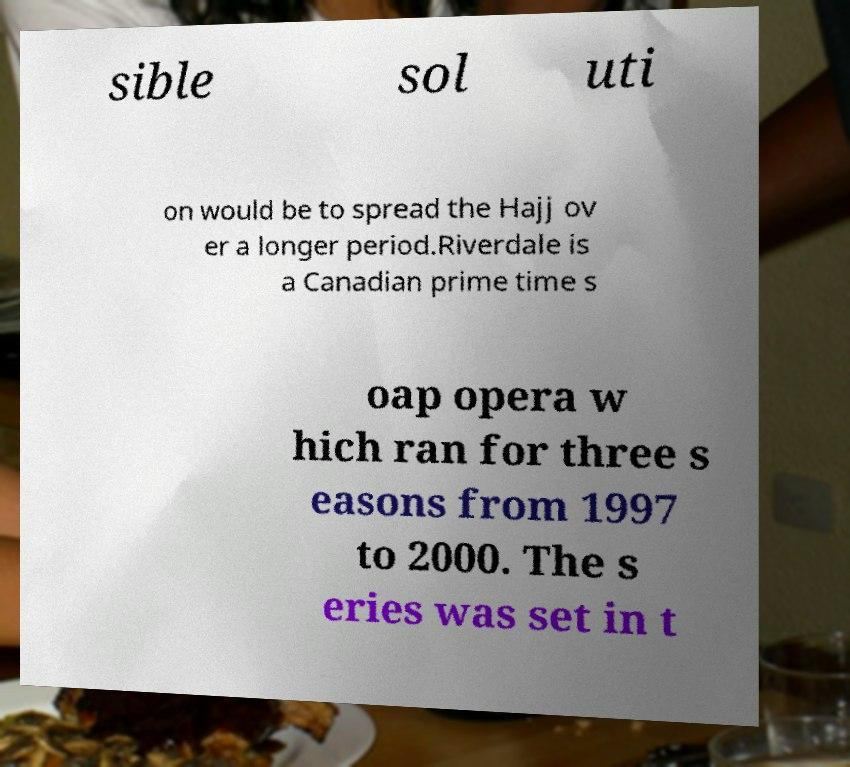Please identify and transcribe the text found in this image. sible sol uti on would be to spread the Hajj ov er a longer period.Riverdale is a Canadian prime time s oap opera w hich ran for three s easons from 1997 to 2000. The s eries was set in t 